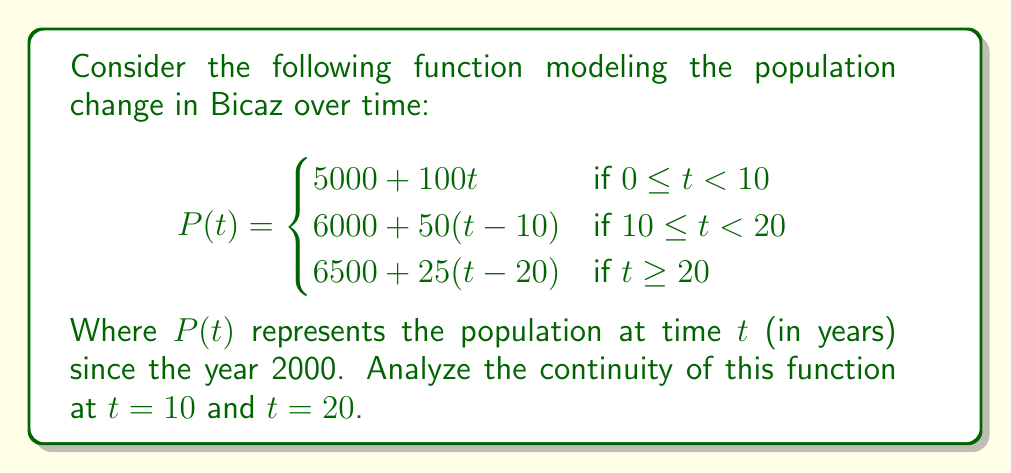Show me your answer to this math problem. To analyze the continuity of the function $P(t)$ at $t = 10$ and $t = 20$, we need to check if the function satisfies the three conditions for continuity at these points:

1. The function must be defined at the point.
2. The limit of the function as we approach the point from both sides must exist.
3. The limit must equal the function value at that point.

For $t = 10$:

1. $P(10)$ is defined: $P(10) = 5000 + 100(10) = 6000$
2. Left-hand limit: $\lim_{t \to 10^-} P(t) = \lim_{t \to 10^-} (5000 + 100t) = 6000$
   Right-hand limit: $\lim_{t \to 10^+} P(t) = \lim_{t \to 10^+} (6000 + 50(t-10)) = 6000$
3. $P(10) = \lim_{t \to 10^-} P(t) = \lim_{t \to 10^+} P(t) = 6000$

For $t = 20$:

1. $P(20)$ is defined: $P(20) = 6000 + 50(20-10) = 6500$
2. Left-hand limit: $\lim_{t \to 20^-} P(t) = \lim_{t \to 20^-} (6000 + 50(t-10)) = 6500$
   Right-hand limit: $\lim_{t \to 20^+} P(t) = \lim_{t \to 20^+} (6500 + 25(t-20)) = 6500$
3. $P(20) = \lim_{t \to 20^-} P(t) = \lim_{t \to 20^+} P(t) = 6500$

Since all three conditions are satisfied at both $t = 10$ and $t = 20$, the function $P(t)$ is continuous at these points.
Answer: The function $P(t)$ is continuous at both $t = 10$ and $t = 20$. 